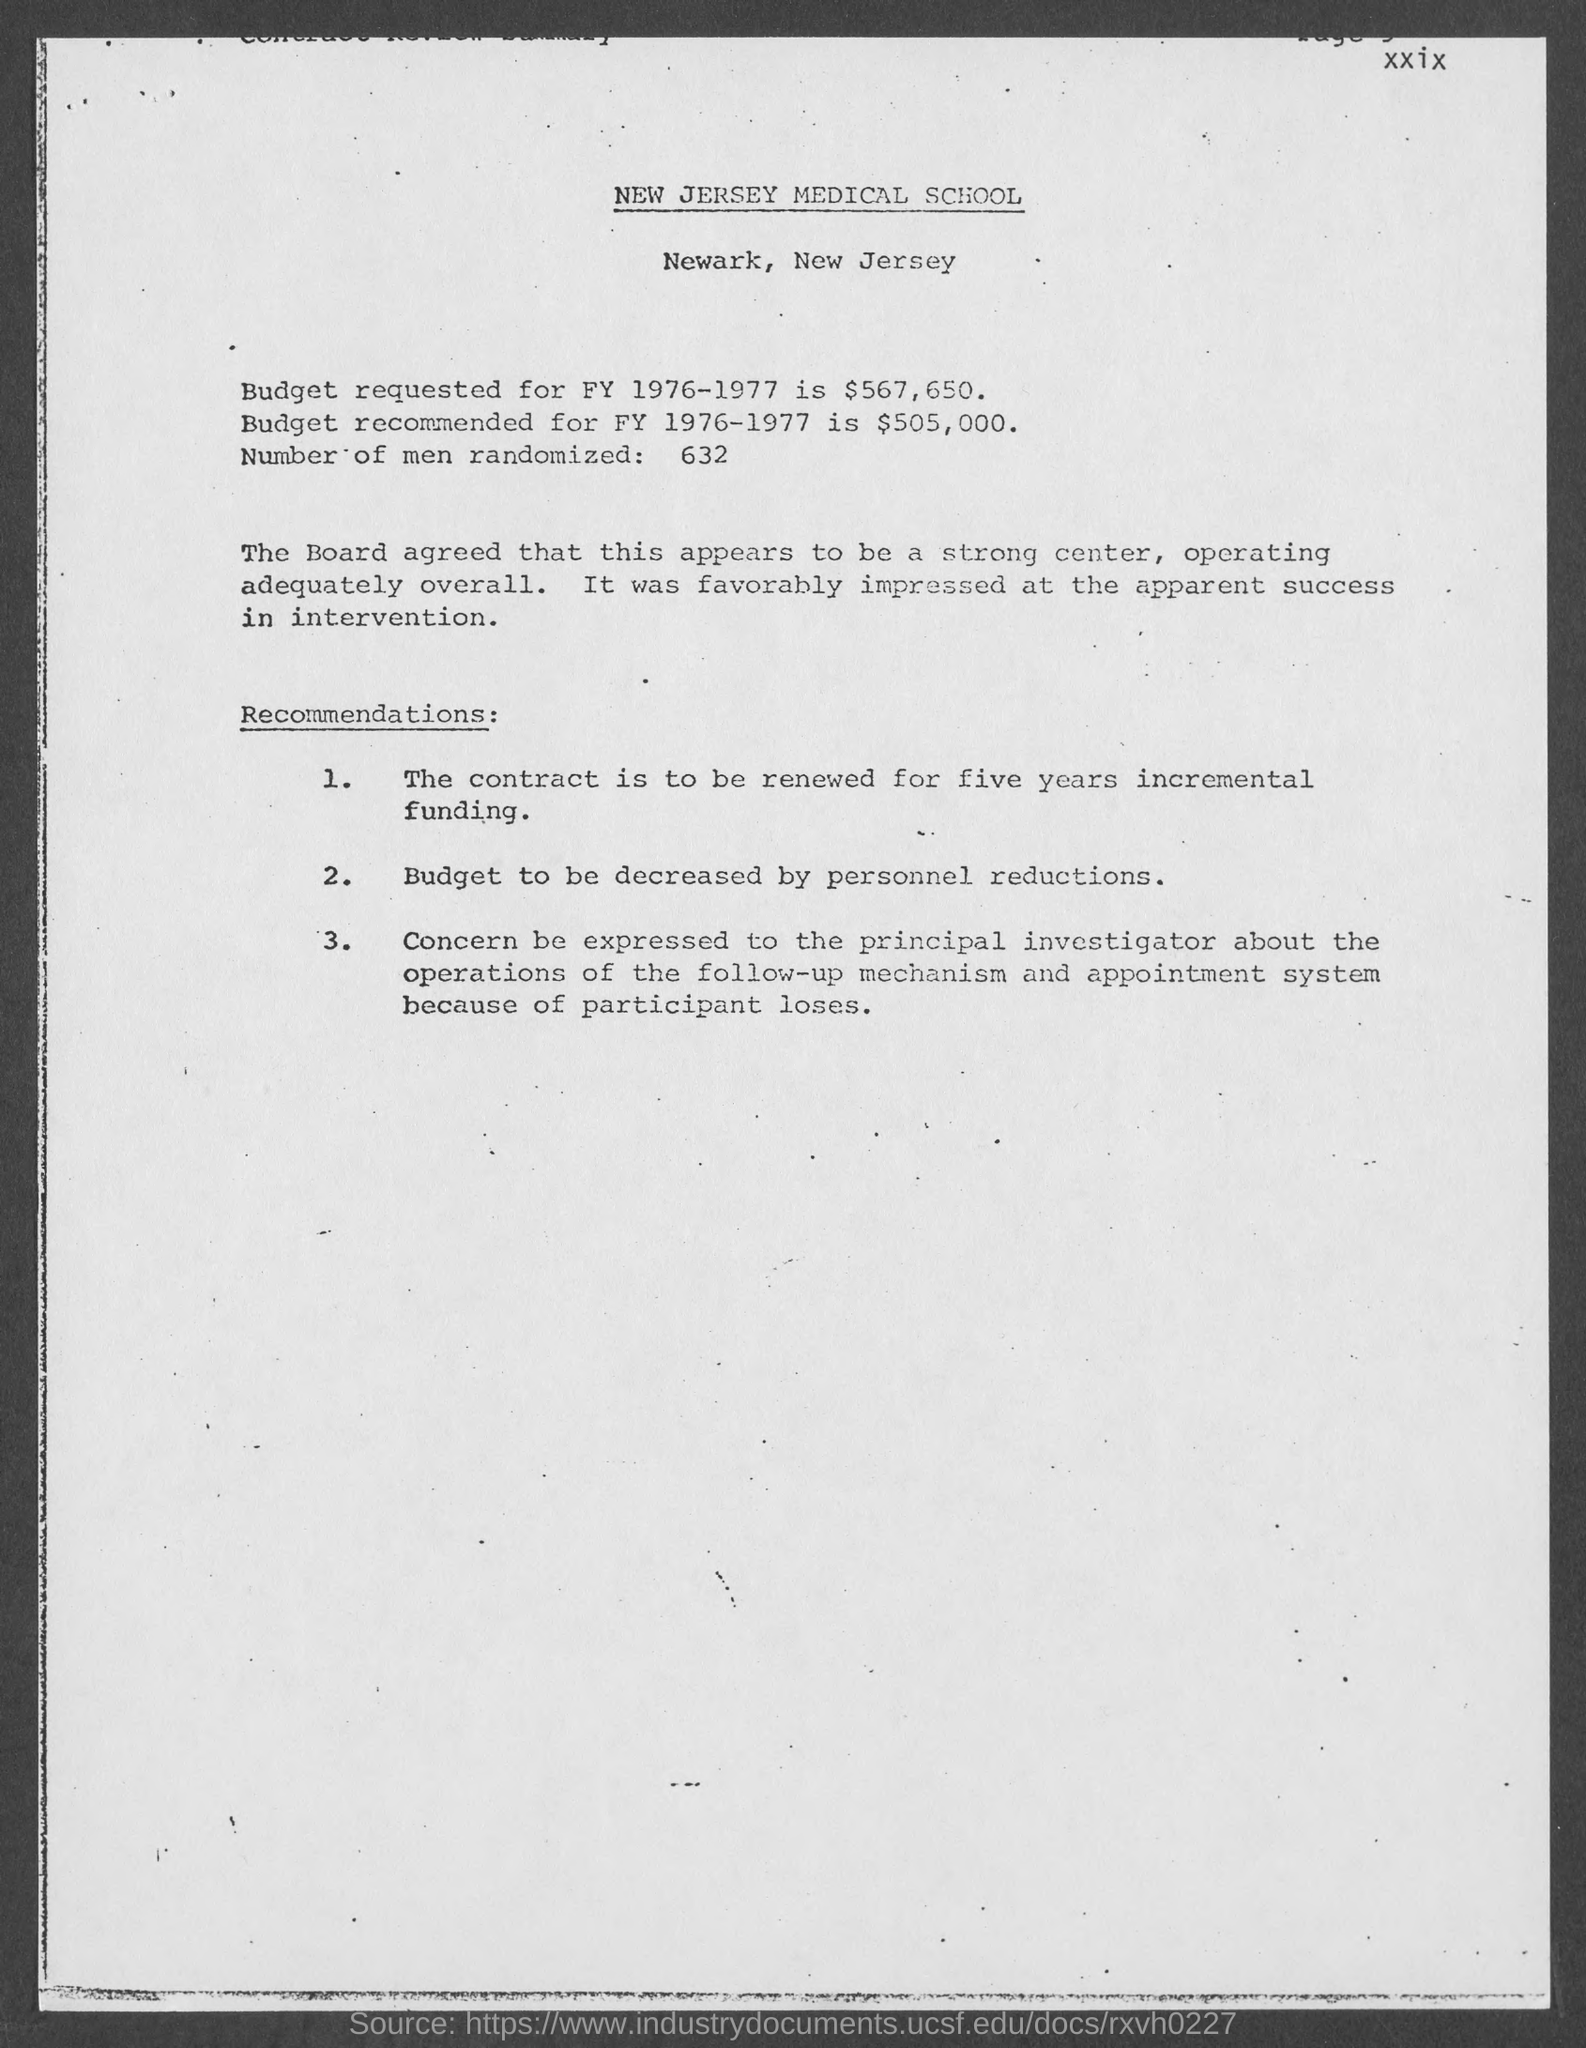Which medical school is mentioned in the header of the document?
Give a very brief answer. NEW JERSEY MEDICAL SCHOOL. What is the Budget requested for FY 1976-1977?
Your response must be concise. $567,650. What is the number of men randomized as per the document?
Offer a very short reply. 632. Who were favorably impressed at the apprarent success in intervention?
Your answer should be very brief. The board. What is the budget recommended for FY 1976-1977?
Give a very brief answer. 505,000. 